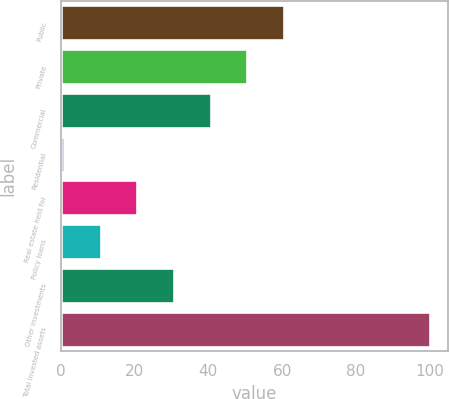Convert chart. <chart><loc_0><loc_0><loc_500><loc_500><bar_chart><fcel>Public<fcel>Private<fcel>Commercial<fcel>Residential<fcel>Real estate held for<fcel>Policy loans<fcel>Other investments<fcel>Total invested assets<nl><fcel>60.4<fcel>50.5<fcel>40.6<fcel>1<fcel>20.8<fcel>10.9<fcel>30.7<fcel>100<nl></chart> 